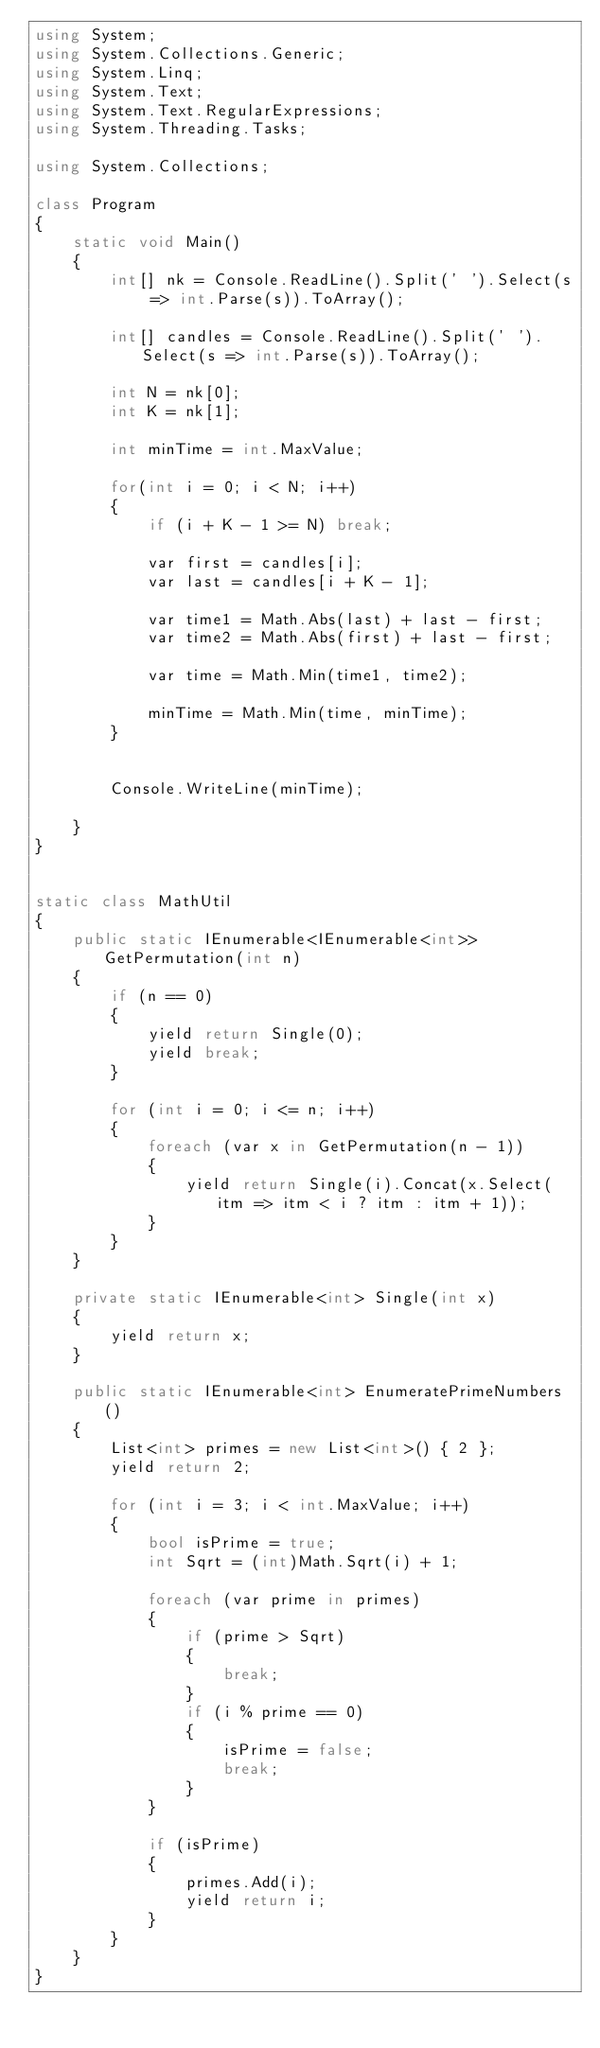Convert code to text. <code><loc_0><loc_0><loc_500><loc_500><_C#_>using System;
using System.Collections.Generic;
using System.Linq;
using System.Text;
using System.Text.RegularExpressions;
using System.Threading.Tasks;

using System.Collections;

class Program
{
    static void Main()
    {
        int[] nk = Console.ReadLine().Split(' ').Select(s => int.Parse(s)).ToArray();

        int[] candles = Console.ReadLine().Split(' ').Select(s => int.Parse(s)).ToArray();

        int N = nk[0];
        int K = nk[1];

        int minTime = int.MaxValue;

        for(int i = 0; i < N; i++)
        {
            if (i + K - 1 >= N) break;

            var first = candles[i];
            var last = candles[i + K - 1];

            var time1 = Math.Abs(last) + last - first;
            var time2 = Math.Abs(first) + last - first;

            var time = Math.Min(time1, time2);

            minTime = Math.Min(time, minTime);
        }


        Console.WriteLine(minTime);

    }
}


static class MathUtil
{
    public static IEnumerable<IEnumerable<int>> GetPermutation(int n)
    {
        if (n == 0)
        {
            yield return Single(0);
            yield break;
        }

        for (int i = 0; i <= n; i++)
        {
            foreach (var x in GetPermutation(n - 1))
            {
                yield return Single(i).Concat(x.Select(itm => itm < i ? itm : itm + 1));
            }
        }
    }

    private static IEnumerable<int> Single(int x)
    {
        yield return x;
    }

    public static IEnumerable<int> EnumeratePrimeNumbers()
    {
        List<int> primes = new List<int>() { 2 };
        yield return 2;

        for (int i = 3; i < int.MaxValue; i++)
        {
            bool isPrime = true;
            int Sqrt = (int)Math.Sqrt(i) + 1;

            foreach (var prime in primes)
            {
                if (prime > Sqrt)
                {
                    break;
                }
                if (i % prime == 0)
                {
                    isPrime = false;
                    break;
                }
            }

            if (isPrime)
            {
                primes.Add(i);
                yield return i;
            }
        }
    }
}
</code> 